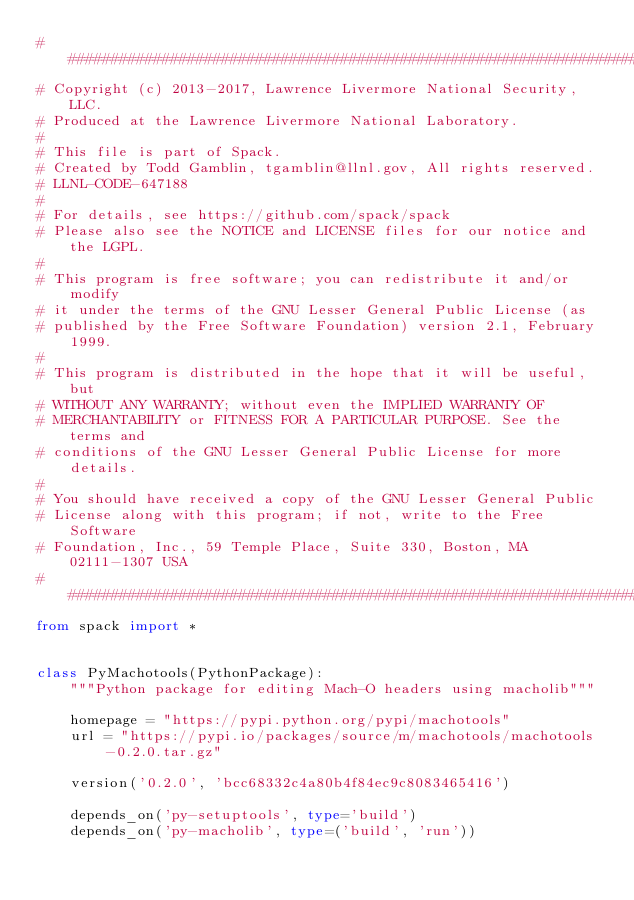Convert code to text. <code><loc_0><loc_0><loc_500><loc_500><_Python_>##############################################################################
# Copyright (c) 2013-2017, Lawrence Livermore National Security, LLC.
# Produced at the Lawrence Livermore National Laboratory.
#
# This file is part of Spack.
# Created by Todd Gamblin, tgamblin@llnl.gov, All rights reserved.
# LLNL-CODE-647188
#
# For details, see https://github.com/spack/spack
# Please also see the NOTICE and LICENSE files for our notice and the LGPL.
#
# This program is free software; you can redistribute it and/or modify
# it under the terms of the GNU Lesser General Public License (as
# published by the Free Software Foundation) version 2.1, February 1999.
#
# This program is distributed in the hope that it will be useful, but
# WITHOUT ANY WARRANTY; without even the IMPLIED WARRANTY OF
# MERCHANTABILITY or FITNESS FOR A PARTICULAR PURPOSE. See the terms and
# conditions of the GNU Lesser General Public License for more details.
#
# You should have received a copy of the GNU Lesser General Public
# License along with this program; if not, write to the Free Software
# Foundation, Inc., 59 Temple Place, Suite 330, Boston, MA 02111-1307 USA
##############################################################################
from spack import *


class PyMachotools(PythonPackage):
    """Python package for editing Mach-O headers using macholib"""

    homepage = "https://pypi.python.org/pypi/machotools"
    url = "https://pypi.io/packages/source/m/machotools/machotools-0.2.0.tar.gz"

    version('0.2.0', 'bcc68332c4a80b4f84ec9c8083465416')

    depends_on('py-setuptools', type='build')
    depends_on('py-macholib', type=('build', 'run'))
</code> 